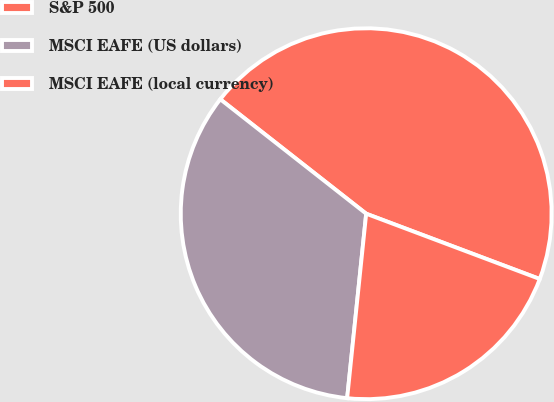<chart> <loc_0><loc_0><loc_500><loc_500><pie_chart><fcel>S&P 500<fcel>MSCI EAFE (US dollars)<fcel>MSCI EAFE (local currency)<nl><fcel>45.14%<fcel>33.95%<fcel>20.91%<nl></chart> 